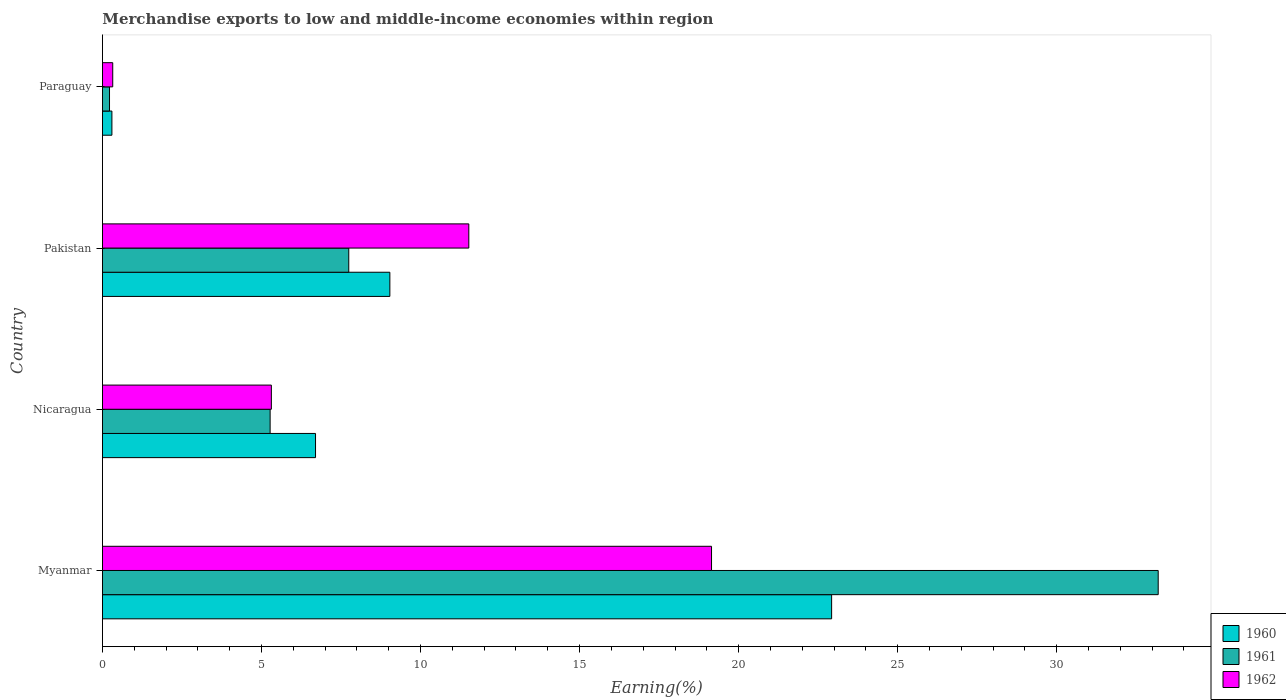How many groups of bars are there?
Provide a succinct answer. 4. Are the number of bars per tick equal to the number of legend labels?
Give a very brief answer. Yes. How many bars are there on the 4th tick from the bottom?
Ensure brevity in your answer.  3. What is the label of the 3rd group of bars from the top?
Offer a terse response. Nicaragua. What is the percentage of amount earned from merchandise exports in 1962 in Paraguay?
Your answer should be very brief. 0.32. Across all countries, what is the maximum percentage of amount earned from merchandise exports in 1962?
Offer a terse response. 19.15. Across all countries, what is the minimum percentage of amount earned from merchandise exports in 1960?
Provide a succinct answer. 0.3. In which country was the percentage of amount earned from merchandise exports in 1962 maximum?
Provide a short and direct response. Myanmar. In which country was the percentage of amount earned from merchandise exports in 1962 minimum?
Provide a succinct answer. Paraguay. What is the total percentage of amount earned from merchandise exports in 1960 in the graph?
Keep it short and to the point. 38.95. What is the difference between the percentage of amount earned from merchandise exports in 1962 in Myanmar and that in Pakistan?
Your answer should be very brief. 7.63. What is the difference between the percentage of amount earned from merchandise exports in 1961 in Nicaragua and the percentage of amount earned from merchandise exports in 1962 in Myanmar?
Keep it short and to the point. -13.88. What is the average percentage of amount earned from merchandise exports in 1961 per country?
Provide a short and direct response. 11.61. What is the difference between the percentage of amount earned from merchandise exports in 1960 and percentage of amount earned from merchandise exports in 1961 in Myanmar?
Offer a very short reply. -10.27. In how many countries, is the percentage of amount earned from merchandise exports in 1961 greater than 24 %?
Make the answer very short. 1. What is the ratio of the percentage of amount earned from merchandise exports in 1962 in Pakistan to that in Paraguay?
Provide a short and direct response. 35.69. Is the percentage of amount earned from merchandise exports in 1960 in Myanmar less than that in Pakistan?
Make the answer very short. No. Is the difference between the percentage of amount earned from merchandise exports in 1960 in Pakistan and Paraguay greater than the difference between the percentage of amount earned from merchandise exports in 1961 in Pakistan and Paraguay?
Offer a terse response. Yes. What is the difference between the highest and the second highest percentage of amount earned from merchandise exports in 1961?
Your response must be concise. 25.45. What is the difference between the highest and the lowest percentage of amount earned from merchandise exports in 1960?
Your answer should be compact. 22.63. In how many countries, is the percentage of amount earned from merchandise exports in 1962 greater than the average percentage of amount earned from merchandise exports in 1962 taken over all countries?
Provide a succinct answer. 2. Is the sum of the percentage of amount earned from merchandise exports in 1961 in Pakistan and Paraguay greater than the maximum percentage of amount earned from merchandise exports in 1960 across all countries?
Make the answer very short. No. What does the 1st bar from the bottom in Nicaragua represents?
Offer a terse response. 1960. Is it the case that in every country, the sum of the percentage of amount earned from merchandise exports in 1961 and percentage of amount earned from merchandise exports in 1962 is greater than the percentage of amount earned from merchandise exports in 1960?
Offer a very short reply. Yes. How many bars are there?
Offer a very short reply. 12. Are all the bars in the graph horizontal?
Your response must be concise. Yes. What is the difference between two consecutive major ticks on the X-axis?
Your answer should be very brief. 5. Are the values on the major ticks of X-axis written in scientific E-notation?
Give a very brief answer. No. Does the graph contain any zero values?
Ensure brevity in your answer.  No. Where does the legend appear in the graph?
Offer a terse response. Bottom right. What is the title of the graph?
Offer a terse response. Merchandise exports to low and middle-income economies within region. Does "2014" appear as one of the legend labels in the graph?
Provide a succinct answer. No. What is the label or title of the X-axis?
Ensure brevity in your answer.  Earning(%). What is the label or title of the Y-axis?
Your response must be concise. Country. What is the Earning(%) of 1960 in Myanmar?
Provide a succinct answer. 22.92. What is the Earning(%) in 1961 in Myanmar?
Provide a short and direct response. 33.19. What is the Earning(%) of 1962 in Myanmar?
Provide a short and direct response. 19.15. What is the Earning(%) in 1960 in Nicaragua?
Make the answer very short. 6.7. What is the Earning(%) in 1961 in Nicaragua?
Give a very brief answer. 5.27. What is the Earning(%) of 1962 in Nicaragua?
Offer a very short reply. 5.31. What is the Earning(%) of 1960 in Pakistan?
Make the answer very short. 9.04. What is the Earning(%) of 1961 in Pakistan?
Your answer should be compact. 7.74. What is the Earning(%) of 1962 in Pakistan?
Provide a succinct answer. 11.52. What is the Earning(%) of 1960 in Paraguay?
Your answer should be very brief. 0.3. What is the Earning(%) in 1961 in Paraguay?
Your response must be concise. 0.22. What is the Earning(%) of 1962 in Paraguay?
Offer a very short reply. 0.32. Across all countries, what is the maximum Earning(%) of 1960?
Your answer should be very brief. 22.92. Across all countries, what is the maximum Earning(%) of 1961?
Give a very brief answer. 33.19. Across all countries, what is the maximum Earning(%) of 1962?
Your answer should be compact. 19.15. Across all countries, what is the minimum Earning(%) of 1960?
Offer a terse response. 0.3. Across all countries, what is the minimum Earning(%) of 1961?
Offer a terse response. 0.22. Across all countries, what is the minimum Earning(%) in 1962?
Your answer should be very brief. 0.32. What is the total Earning(%) in 1960 in the graph?
Provide a succinct answer. 38.95. What is the total Earning(%) in 1961 in the graph?
Your response must be concise. 46.43. What is the total Earning(%) of 1962 in the graph?
Your response must be concise. 36.3. What is the difference between the Earning(%) in 1960 in Myanmar and that in Nicaragua?
Keep it short and to the point. 16.22. What is the difference between the Earning(%) in 1961 in Myanmar and that in Nicaragua?
Provide a succinct answer. 27.92. What is the difference between the Earning(%) in 1962 in Myanmar and that in Nicaragua?
Offer a terse response. 13.84. What is the difference between the Earning(%) in 1960 in Myanmar and that in Pakistan?
Your answer should be very brief. 13.89. What is the difference between the Earning(%) in 1961 in Myanmar and that in Pakistan?
Make the answer very short. 25.45. What is the difference between the Earning(%) in 1962 in Myanmar and that in Pakistan?
Provide a succinct answer. 7.63. What is the difference between the Earning(%) in 1960 in Myanmar and that in Paraguay?
Ensure brevity in your answer.  22.63. What is the difference between the Earning(%) in 1961 in Myanmar and that in Paraguay?
Your response must be concise. 32.97. What is the difference between the Earning(%) in 1962 in Myanmar and that in Paraguay?
Your response must be concise. 18.83. What is the difference between the Earning(%) in 1960 in Nicaragua and that in Pakistan?
Give a very brief answer. -2.34. What is the difference between the Earning(%) of 1961 in Nicaragua and that in Pakistan?
Ensure brevity in your answer.  -2.47. What is the difference between the Earning(%) in 1962 in Nicaragua and that in Pakistan?
Ensure brevity in your answer.  -6.21. What is the difference between the Earning(%) of 1960 in Nicaragua and that in Paraguay?
Your answer should be compact. 6.4. What is the difference between the Earning(%) in 1961 in Nicaragua and that in Paraguay?
Provide a succinct answer. 5.05. What is the difference between the Earning(%) in 1962 in Nicaragua and that in Paraguay?
Your response must be concise. 4.99. What is the difference between the Earning(%) in 1960 in Pakistan and that in Paraguay?
Your answer should be compact. 8.74. What is the difference between the Earning(%) in 1961 in Pakistan and that in Paraguay?
Offer a terse response. 7.52. What is the difference between the Earning(%) of 1962 in Pakistan and that in Paraguay?
Make the answer very short. 11.19. What is the difference between the Earning(%) of 1960 in Myanmar and the Earning(%) of 1961 in Nicaragua?
Give a very brief answer. 17.65. What is the difference between the Earning(%) of 1960 in Myanmar and the Earning(%) of 1962 in Nicaragua?
Provide a short and direct response. 17.61. What is the difference between the Earning(%) in 1961 in Myanmar and the Earning(%) in 1962 in Nicaragua?
Your answer should be compact. 27.88. What is the difference between the Earning(%) of 1960 in Myanmar and the Earning(%) of 1961 in Pakistan?
Your answer should be compact. 15.18. What is the difference between the Earning(%) of 1960 in Myanmar and the Earning(%) of 1962 in Pakistan?
Offer a terse response. 11.41. What is the difference between the Earning(%) in 1961 in Myanmar and the Earning(%) in 1962 in Pakistan?
Your answer should be very brief. 21.67. What is the difference between the Earning(%) in 1960 in Myanmar and the Earning(%) in 1961 in Paraguay?
Keep it short and to the point. 22.7. What is the difference between the Earning(%) of 1960 in Myanmar and the Earning(%) of 1962 in Paraguay?
Ensure brevity in your answer.  22.6. What is the difference between the Earning(%) in 1961 in Myanmar and the Earning(%) in 1962 in Paraguay?
Provide a short and direct response. 32.87. What is the difference between the Earning(%) in 1960 in Nicaragua and the Earning(%) in 1961 in Pakistan?
Provide a short and direct response. -1.04. What is the difference between the Earning(%) of 1960 in Nicaragua and the Earning(%) of 1962 in Pakistan?
Your response must be concise. -4.82. What is the difference between the Earning(%) in 1961 in Nicaragua and the Earning(%) in 1962 in Pakistan?
Offer a terse response. -6.25. What is the difference between the Earning(%) in 1960 in Nicaragua and the Earning(%) in 1961 in Paraguay?
Offer a terse response. 6.48. What is the difference between the Earning(%) in 1960 in Nicaragua and the Earning(%) in 1962 in Paraguay?
Offer a very short reply. 6.38. What is the difference between the Earning(%) of 1961 in Nicaragua and the Earning(%) of 1962 in Paraguay?
Make the answer very short. 4.95. What is the difference between the Earning(%) of 1960 in Pakistan and the Earning(%) of 1961 in Paraguay?
Give a very brief answer. 8.81. What is the difference between the Earning(%) in 1960 in Pakistan and the Earning(%) in 1962 in Paraguay?
Make the answer very short. 8.71. What is the difference between the Earning(%) of 1961 in Pakistan and the Earning(%) of 1962 in Paraguay?
Offer a very short reply. 7.42. What is the average Earning(%) in 1960 per country?
Offer a very short reply. 9.74. What is the average Earning(%) in 1961 per country?
Your answer should be very brief. 11.61. What is the average Earning(%) of 1962 per country?
Offer a very short reply. 9.07. What is the difference between the Earning(%) in 1960 and Earning(%) in 1961 in Myanmar?
Ensure brevity in your answer.  -10.27. What is the difference between the Earning(%) of 1960 and Earning(%) of 1962 in Myanmar?
Provide a short and direct response. 3.78. What is the difference between the Earning(%) of 1961 and Earning(%) of 1962 in Myanmar?
Make the answer very short. 14.04. What is the difference between the Earning(%) of 1960 and Earning(%) of 1961 in Nicaragua?
Offer a terse response. 1.43. What is the difference between the Earning(%) of 1960 and Earning(%) of 1962 in Nicaragua?
Provide a short and direct response. 1.39. What is the difference between the Earning(%) of 1961 and Earning(%) of 1962 in Nicaragua?
Keep it short and to the point. -0.04. What is the difference between the Earning(%) of 1960 and Earning(%) of 1961 in Pakistan?
Provide a short and direct response. 1.29. What is the difference between the Earning(%) of 1960 and Earning(%) of 1962 in Pakistan?
Offer a very short reply. -2.48. What is the difference between the Earning(%) in 1961 and Earning(%) in 1962 in Pakistan?
Provide a short and direct response. -3.77. What is the difference between the Earning(%) in 1960 and Earning(%) in 1961 in Paraguay?
Provide a short and direct response. 0.07. What is the difference between the Earning(%) in 1960 and Earning(%) in 1962 in Paraguay?
Give a very brief answer. -0.03. What is the difference between the Earning(%) in 1961 and Earning(%) in 1962 in Paraguay?
Give a very brief answer. -0.1. What is the ratio of the Earning(%) of 1960 in Myanmar to that in Nicaragua?
Provide a succinct answer. 3.42. What is the ratio of the Earning(%) in 1961 in Myanmar to that in Nicaragua?
Your answer should be very brief. 6.3. What is the ratio of the Earning(%) of 1962 in Myanmar to that in Nicaragua?
Ensure brevity in your answer.  3.61. What is the ratio of the Earning(%) of 1960 in Myanmar to that in Pakistan?
Offer a terse response. 2.54. What is the ratio of the Earning(%) of 1961 in Myanmar to that in Pakistan?
Offer a very short reply. 4.29. What is the ratio of the Earning(%) in 1962 in Myanmar to that in Pakistan?
Provide a succinct answer. 1.66. What is the ratio of the Earning(%) of 1960 in Myanmar to that in Paraguay?
Keep it short and to the point. 77.3. What is the ratio of the Earning(%) of 1961 in Myanmar to that in Paraguay?
Keep it short and to the point. 149.73. What is the ratio of the Earning(%) of 1962 in Myanmar to that in Paraguay?
Your answer should be compact. 59.34. What is the ratio of the Earning(%) of 1960 in Nicaragua to that in Pakistan?
Your answer should be very brief. 0.74. What is the ratio of the Earning(%) of 1961 in Nicaragua to that in Pakistan?
Offer a terse response. 0.68. What is the ratio of the Earning(%) of 1962 in Nicaragua to that in Pakistan?
Make the answer very short. 0.46. What is the ratio of the Earning(%) of 1960 in Nicaragua to that in Paraguay?
Provide a short and direct response. 22.59. What is the ratio of the Earning(%) in 1961 in Nicaragua to that in Paraguay?
Give a very brief answer. 23.78. What is the ratio of the Earning(%) in 1962 in Nicaragua to that in Paraguay?
Provide a short and direct response. 16.45. What is the ratio of the Earning(%) in 1960 in Pakistan to that in Paraguay?
Give a very brief answer. 30.47. What is the ratio of the Earning(%) of 1961 in Pakistan to that in Paraguay?
Offer a very short reply. 34.93. What is the ratio of the Earning(%) in 1962 in Pakistan to that in Paraguay?
Make the answer very short. 35.69. What is the difference between the highest and the second highest Earning(%) of 1960?
Give a very brief answer. 13.89. What is the difference between the highest and the second highest Earning(%) in 1961?
Your response must be concise. 25.45. What is the difference between the highest and the second highest Earning(%) in 1962?
Make the answer very short. 7.63. What is the difference between the highest and the lowest Earning(%) in 1960?
Offer a very short reply. 22.63. What is the difference between the highest and the lowest Earning(%) of 1961?
Make the answer very short. 32.97. What is the difference between the highest and the lowest Earning(%) of 1962?
Ensure brevity in your answer.  18.83. 